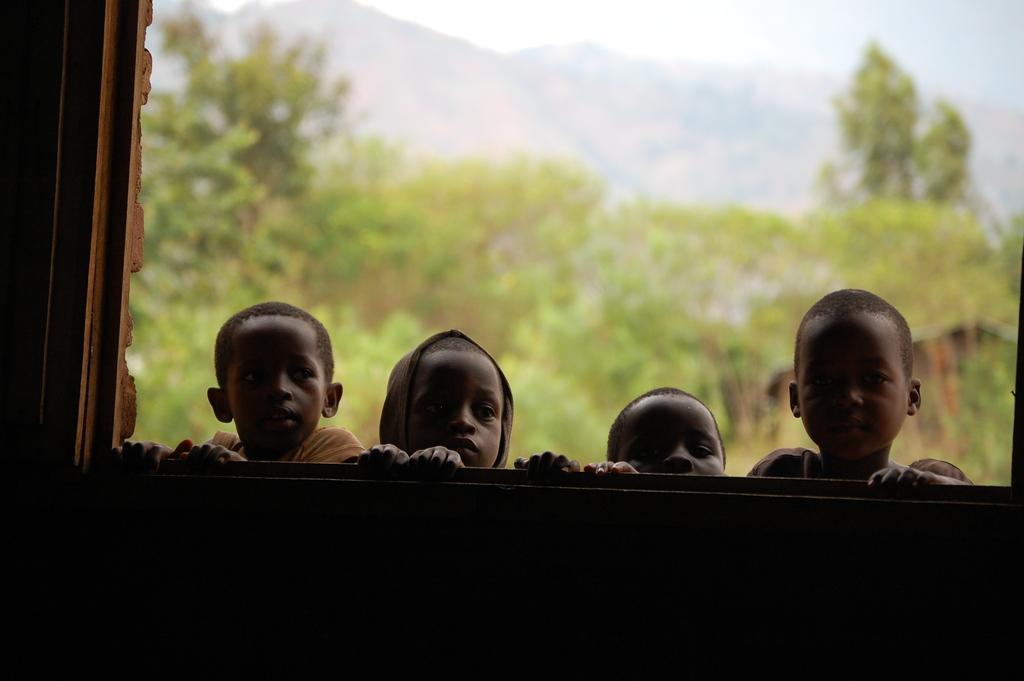Please provide a concise description of this image. In this image we can see a group of boys are standing, here is the window, here are the trees, here are the mountains, at above here is the sky. 